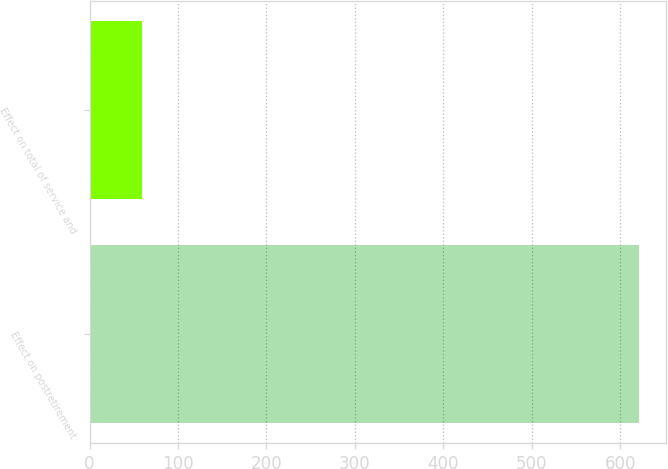Convert chart to OTSL. <chart><loc_0><loc_0><loc_500><loc_500><bar_chart><fcel>Effect on postretirement<fcel>Effect on total of service and<nl><fcel>621<fcel>59<nl></chart> 